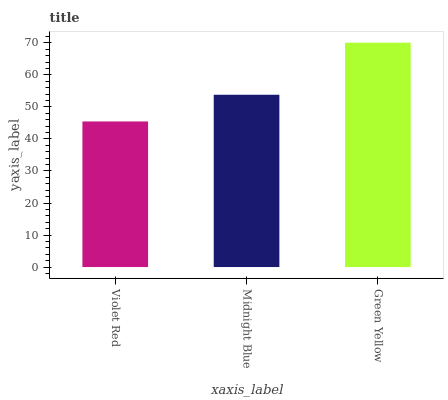Is Violet Red the minimum?
Answer yes or no. Yes. Is Green Yellow the maximum?
Answer yes or no. Yes. Is Midnight Blue the minimum?
Answer yes or no. No. Is Midnight Blue the maximum?
Answer yes or no. No. Is Midnight Blue greater than Violet Red?
Answer yes or no. Yes. Is Violet Red less than Midnight Blue?
Answer yes or no. Yes. Is Violet Red greater than Midnight Blue?
Answer yes or no. No. Is Midnight Blue less than Violet Red?
Answer yes or no. No. Is Midnight Blue the high median?
Answer yes or no. Yes. Is Midnight Blue the low median?
Answer yes or no. Yes. Is Violet Red the high median?
Answer yes or no. No. Is Green Yellow the low median?
Answer yes or no. No. 